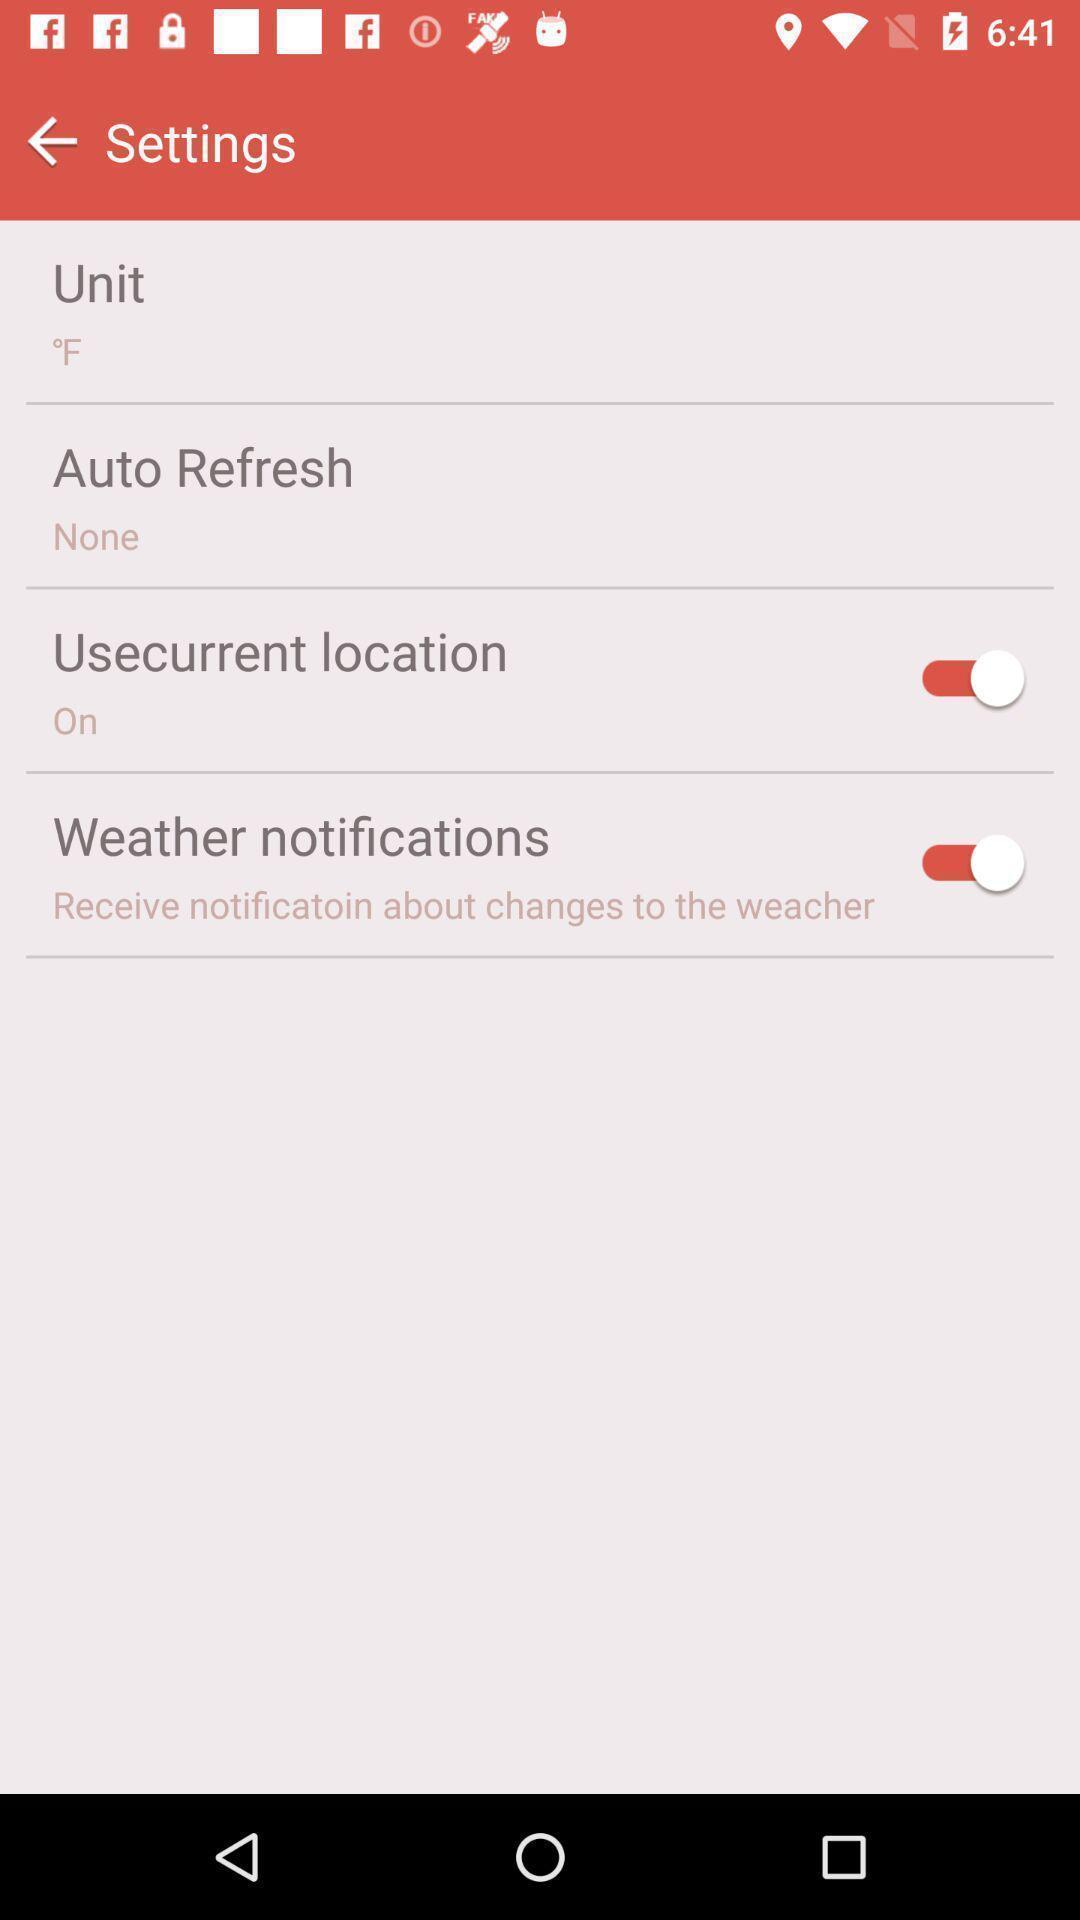What can you discern from this picture? Screen showing the settings page. 